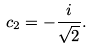<formula> <loc_0><loc_0><loc_500><loc_500>c _ { 2 } = - \frac { i } { \sqrt { 2 } } .</formula> 